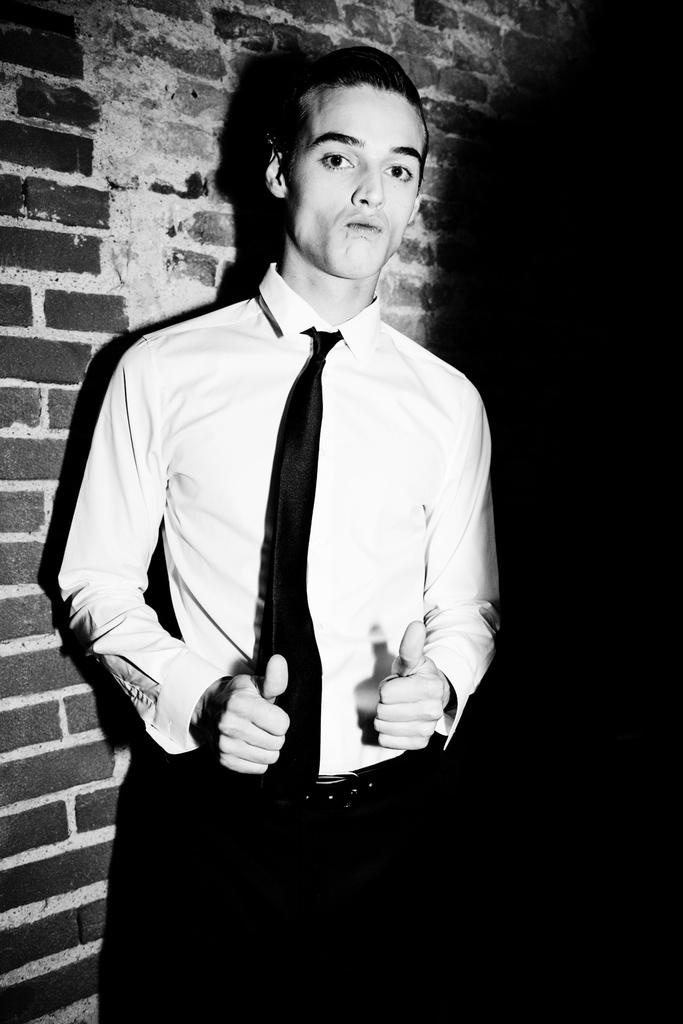What type of structure is visible in the image? There is a brick wall in the image. Can you describe the person in the image? The person in the image is wearing a white shirt. What statement does the person make about their experience with the brick wall in the image? There is no statement or conversation present in the image, so it is not possible to determine what the person might say about their experience with the brick wall. 